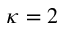<formula> <loc_0><loc_0><loc_500><loc_500>\kappa = 2</formula> 